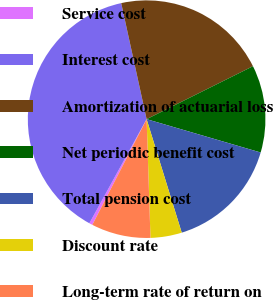Convert chart to OTSL. <chart><loc_0><loc_0><loc_500><loc_500><pie_chart><fcel>Service cost<fcel>Interest cost<fcel>Amortization of actuarial loss<fcel>Net periodic benefit cost<fcel>Total pension cost<fcel>Discount rate<fcel>Long-term rate of return on<nl><fcel>0.45%<fcel>38.57%<fcel>21.08%<fcel>11.88%<fcel>15.7%<fcel>4.26%<fcel>8.07%<nl></chart> 